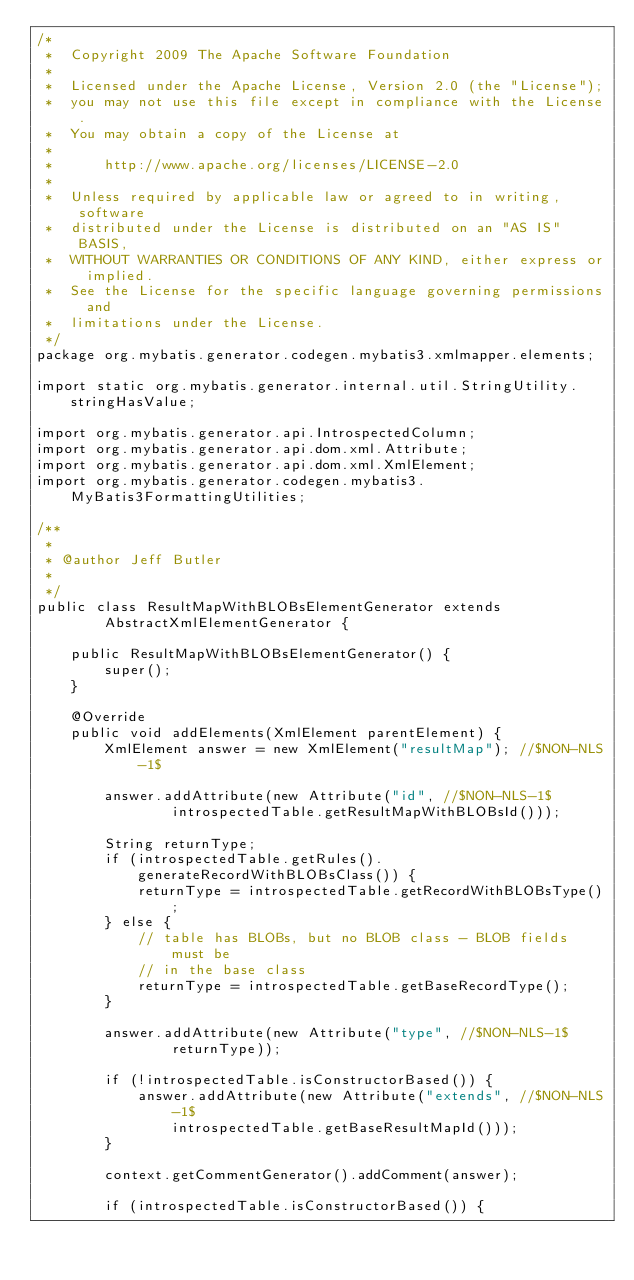<code> <loc_0><loc_0><loc_500><loc_500><_Java_>/*
 *  Copyright 2009 The Apache Software Foundation
 *
 *  Licensed under the Apache License, Version 2.0 (the "License");
 *  you may not use this file except in compliance with the License.
 *  You may obtain a copy of the License at
 *
 *      http://www.apache.org/licenses/LICENSE-2.0
 *
 *  Unless required by applicable law or agreed to in writing, software
 *  distributed under the License is distributed on an "AS IS" BASIS,
 *  WITHOUT WARRANTIES OR CONDITIONS OF ANY KIND, either express or implied.
 *  See the License for the specific language governing permissions and
 *  limitations under the License.
 */
package org.mybatis.generator.codegen.mybatis3.xmlmapper.elements;

import static org.mybatis.generator.internal.util.StringUtility.stringHasValue;

import org.mybatis.generator.api.IntrospectedColumn;
import org.mybatis.generator.api.dom.xml.Attribute;
import org.mybatis.generator.api.dom.xml.XmlElement;
import org.mybatis.generator.codegen.mybatis3.MyBatis3FormattingUtilities;

/**
 * 
 * @author Jeff Butler
 * 
 */
public class ResultMapWithBLOBsElementGenerator extends
        AbstractXmlElementGenerator {

    public ResultMapWithBLOBsElementGenerator() {
        super();
    }

    @Override
    public void addElements(XmlElement parentElement) {
        XmlElement answer = new XmlElement("resultMap"); //$NON-NLS-1$

        answer.addAttribute(new Attribute("id", //$NON-NLS-1$
                introspectedTable.getResultMapWithBLOBsId()));

        String returnType;
        if (introspectedTable.getRules().generateRecordWithBLOBsClass()) {
            returnType = introspectedTable.getRecordWithBLOBsType();
        } else {
            // table has BLOBs, but no BLOB class - BLOB fields must be
            // in the base class
            returnType = introspectedTable.getBaseRecordType();
        }

        answer.addAttribute(new Attribute("type", //$NON-NLS-1$
                returnType));

        if (!introspectedTable.isConstructorBased()) {
            answer.addAttribute(new Attribute("extends", //$NON-NLS-1$
                introspectedTable.getBaseResultMapId()));
        }

        context.getCommentGenerator().addComment(answer);

        if (introspectedTable.isConstructorBased()) {</code> 